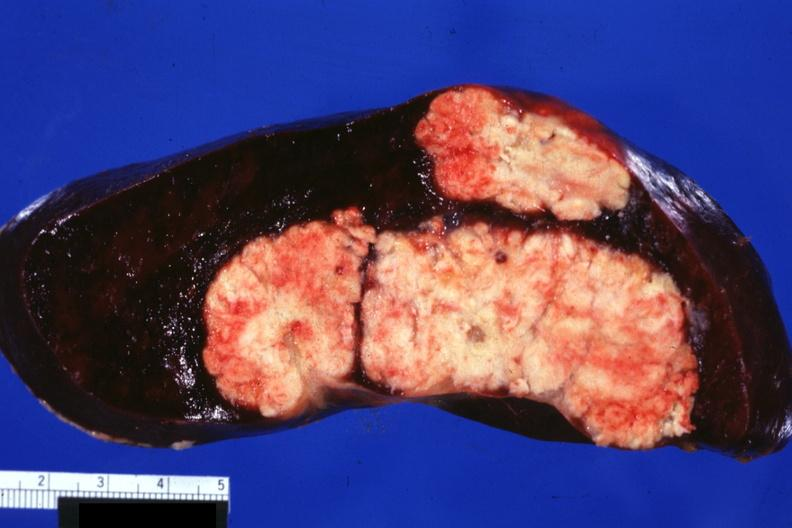what is present?
Answer the question using a single word or phrase. Metastatic carcinoma colon 